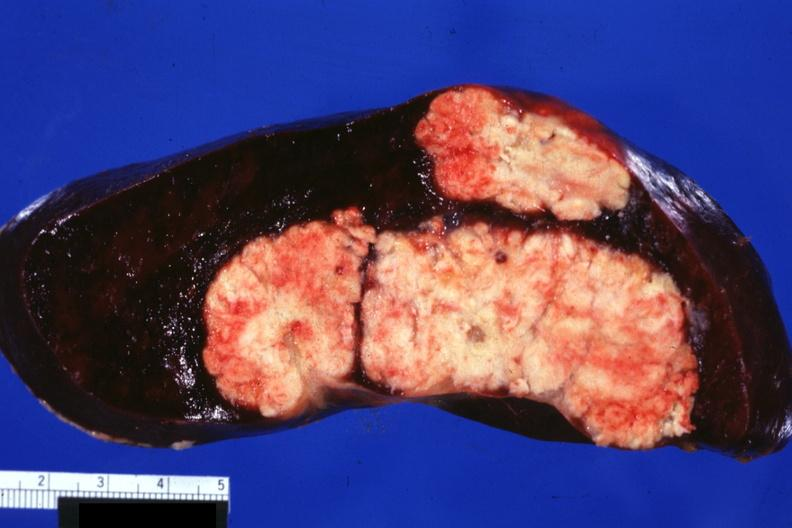what is present?
Answer the question using a single word or phrase. Metastatic carcinoma colon 